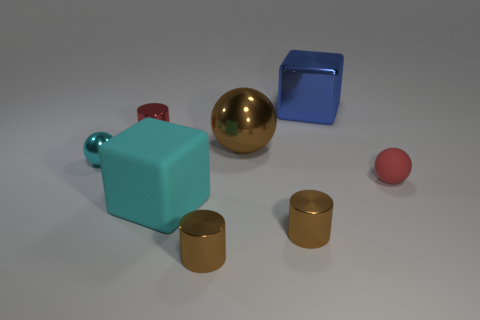There is a small cylinder that is the same color as the matte sphere; what is it made of?
Your answer should be very brief. Metal. There is a tiny shiny ball; is it the same color as the big cube that is on the left side of the large blue metal cube?
Ensure brevity in your answer.  Yes. What is the color of the block behind the cylinder behind the tiny sphere left of the large blue metallic cube?
Your response must be concise. Blue. There is a shiny cylinder behind the cyan block; how many blocks are in front of it?
Provide a short and direct response. 1. How many other things are there of the same shape as the big cyan matte thing?
Make the answer very short. 1. What number of things are either big green matte cubes or small brown cylinders on the left side of the brown ball?
Your answer should be compact. 1. Is the number of big metal balls that are in front of the red cylinder greater than the number of tiny cyan shiny objects that are in front of the rubber cube?
Provide a short and direct response. Yes. What shape is the matte thing right of the block that is behind the cyan object behind the big cyan cube?
Your answer should be very brief. Sphere. There is a red object on the right side of the rubber thing in front of the small red matte object; what is its shape?
Ensure brevity in your answer.  Sphere. Is there a brown cylinder made of the same material as the big ball?
Provide a short and direct response. Yes. 